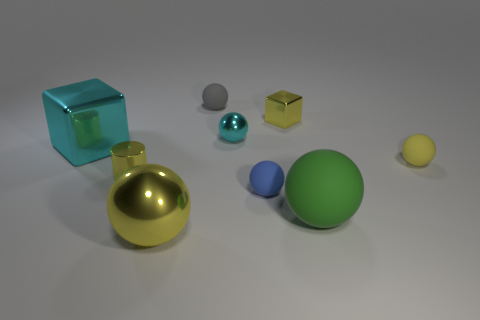Subtract all large metallic balls. How many balls are left? 5 Subtract all cyan blocks. How many yellow balls are left? 2 Subtract all cyan balls. How many balls are left? 5 Subtract all cylinders. How many objects are left? 8 Subtract all blue cylinders. Subtract all yellow cubes. How many cylinders are left? 1 Subtract all tiny blocks. Subtract all yellow metallic cylinders. How many objects are left? 7 Add 7 large shiny things. How many large shiny things are left? 9 Add 8 big shiny cubes. How many big shiny cubes exist? 9 Add 1 green matte things. How many objects exist? 10 Subtract 1 green spheres. How many objects are left? 8 